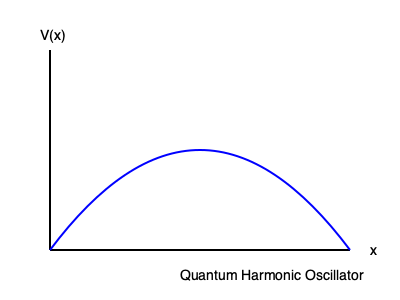In a numerical simulation of a quantum harmonic oscillator using the path integral formalism, you discretize the path into $N$ segments. If the potential energy is given by $V(x) = \frac{1}{2}m\omega^2x^2$, and you use the midpoint approximation for the action, what is the expression for the discretized action $S_N$ in terms of $N$, $\epsilon = \frac{\beta}{N}$, $m$, $\omega$, and the positions $x_j$? To derive the discretized action for the quantum harmonic oscillator using the path integral formalism, we follow these steps:

1) The general form of the action in imaginary time is:
   $$S[x(\tau)] = \int_0^\beta d\tau \left[\frac{1}{2}m\left(\frac{dx}{d\tau}\right)^2 + V(x(\tau))\right]$$

2) For the harmonic oscillator, $V(x) = \frac{1}{2}m\omega^2x^2$.

3) We discretize the path into $N$ segments, each of length $\epsilon = \frac{\beta}{N}$.

4) The discretized version of $\frac{dx}{d\tau}$ becomes $\frac{x_{j+1} - x_j}{\epsilon}$.

5) Using the midpoint approximation for the potential, we evaluate $V(x)$ at $\frac{x_{j+1} + x_j}{2}$.

6) The discretized action becomes:
   $$S_N = \epsilon \sum_{j=1}^N \left[\frac{m}{2}\left(\frac{x_{j+1} - x_j}{\epsilon}\right)^2 + \frac{1}{2}m\omega^2\left(\frac{x_{j+1} + x_j}{2}\right)^2\right]$$

7) Expanding and simplifying:
   $$S_N = \sum_{j=1}^N \left[\frac{m}{2\epsilon}(x_{j+1}^2 - 2x_{j+1}x_j + x_j^2) + \frac{m\omega^2\epsilon}{8}(x_{j+1}^2 + 2x_{j+1}x_j + x_j^2)\right]$$

8) Collecting terms:
   $$S_N = \sum_{j=1}^N \left[\left(\frac{m}{2\epsilon} + \frac{m\omega^2\epsilon}{8}\right)(x_{j+1}^2 + x_j^2) - \frac{m}{\epsilon}x_{j+1}x_j + \frac{m\omega^2\epsilon}{4}x_{j+1}x_j\right]$$

This is the final expression for the discretized action $S_N$.
Answer: $$S_N = \sum_{j=1}^N \left[\left(\frac{m}{2\epsilon} + \frac{m\omega^2\epsilon}{8}\right)(x_{j+1}^2 + x_j^2) + \left(\frac{m\omega^2\epsilon}{4} - \frac{m}{\epsilon}\right)x_{j+1}x_j\right]$$ 